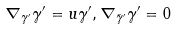<formula> <loc_0><loc_0><loc_500><loc_500>\nabla _ { \gamma ^ { \prime } } \gamma ^ { \prime } = u \gamma ^ { \prime } , \nabla _ { \bar { \gamma } ^ { \prime } } \gamma ^ { \prime } = 0</formula> 